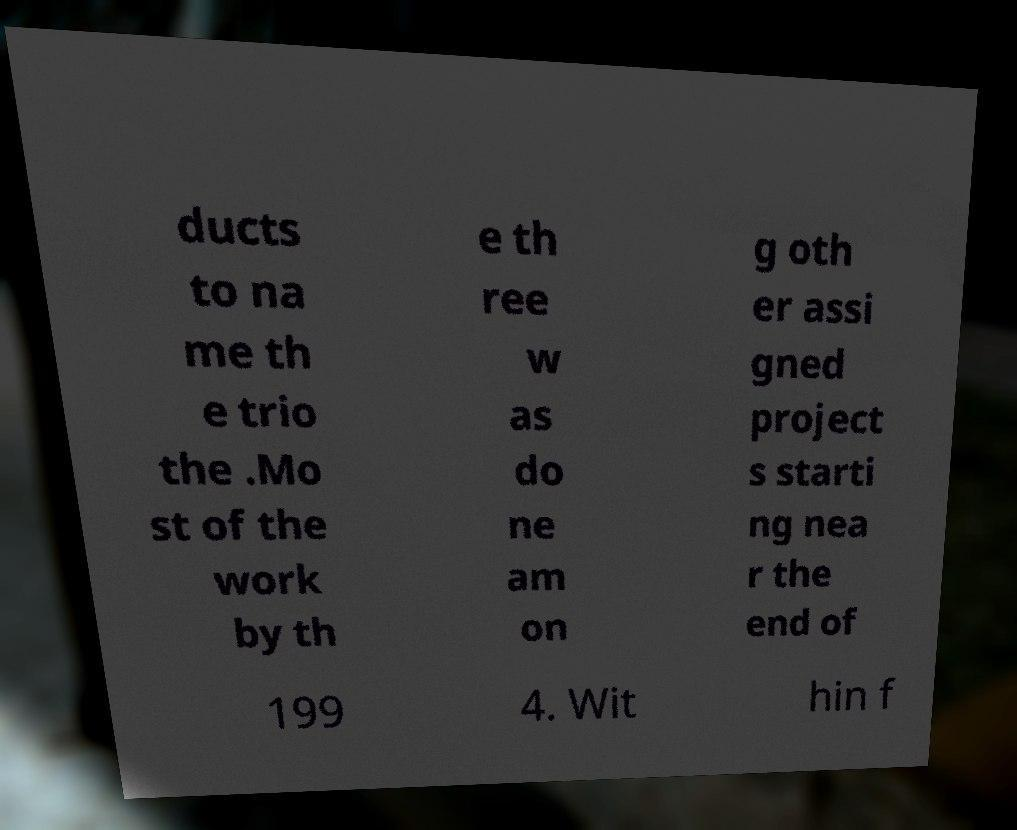What messages or text are displayed in this image? I need them in a readable, typed format. ducts to na me th e trio the .Mo st of the work by th e th ree w as do ne am on g oth er assi gned project s starti ng nea r the end of 199 4. Wit hin f 